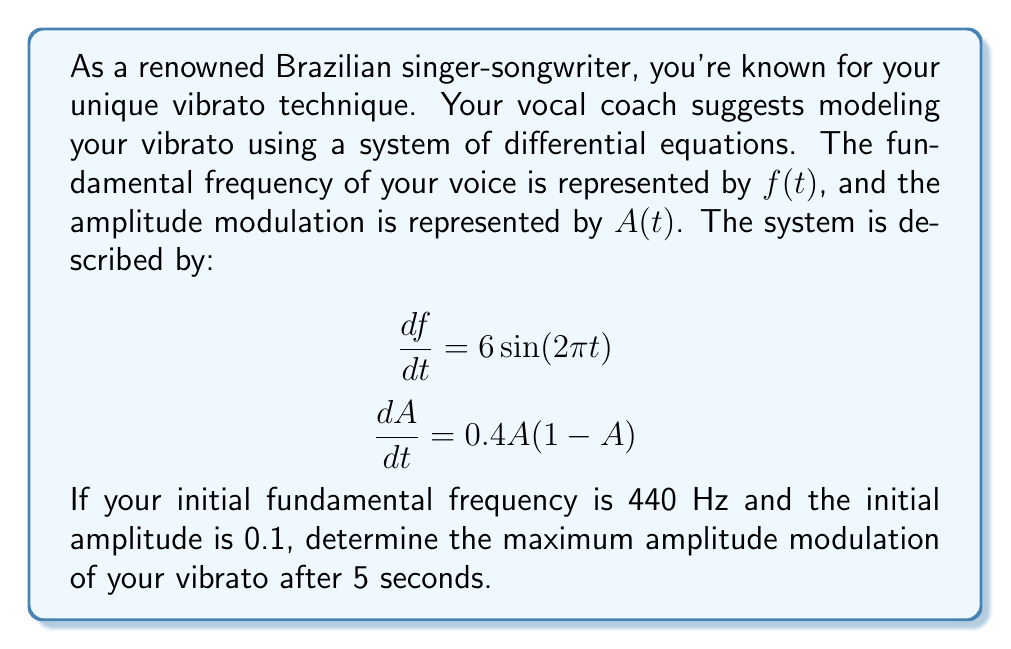Solve this math problem. To solve this problem, we need to focus on the amplitude modulation equation, as it's independent of the frequency equation:

$$\frac{dA}{dt} = 0.4A(1-A)$$

This is a separable differential equation known as the logistic equation. We can solve it as follows:

1) Separate the variables:
   $$\frac{dA}{A(1-A)} = 0.4dt$$

2) Integrate both sides:
   $$\int \frac{dA}{A(1-A)} = \int 0.4dt$$

3) The left-hand side integrates to:
   $$-\ln|1-A| + \ln|A| = 0.4t + C$$

4) Simplify and solve for A:
   $$\ln|\frac{A}{1-A}| = 0.4t + C$$
   $$\frac{A}{1-A} = Ke^{0.4t}$$, where $K = e^C$

5) Solve for A:
   $$A = \frac{Ke^{0.4t}}{1+Ke^{0.4t}}$$

6) Use the initial condition A(0) = 0.1 to find K:
   $$0.1 = \frac{K}{1+K}$$
   $$K = \frac{1}{9}$$

7) Therefore, the solution for A(t) is:
   $$A(t) = \frac{e^{0.4t}/9}{1+e^{0.4t}/9}$$

8) As t approaches infinity, A(t) approaches 1, which is the maximum possible amplitude.

9) To find A(5), we calculate:
   $$A(5) = \frac{e^2/9}{1+e^2/9} \approx 0.8175$$

Therefore, the maximum amplitude modulation after 5 seconds is approximately 0.8175.
Answer: The maximum amplitude modulation of the vibrato after 5 seconds is approximately 0.8175. 